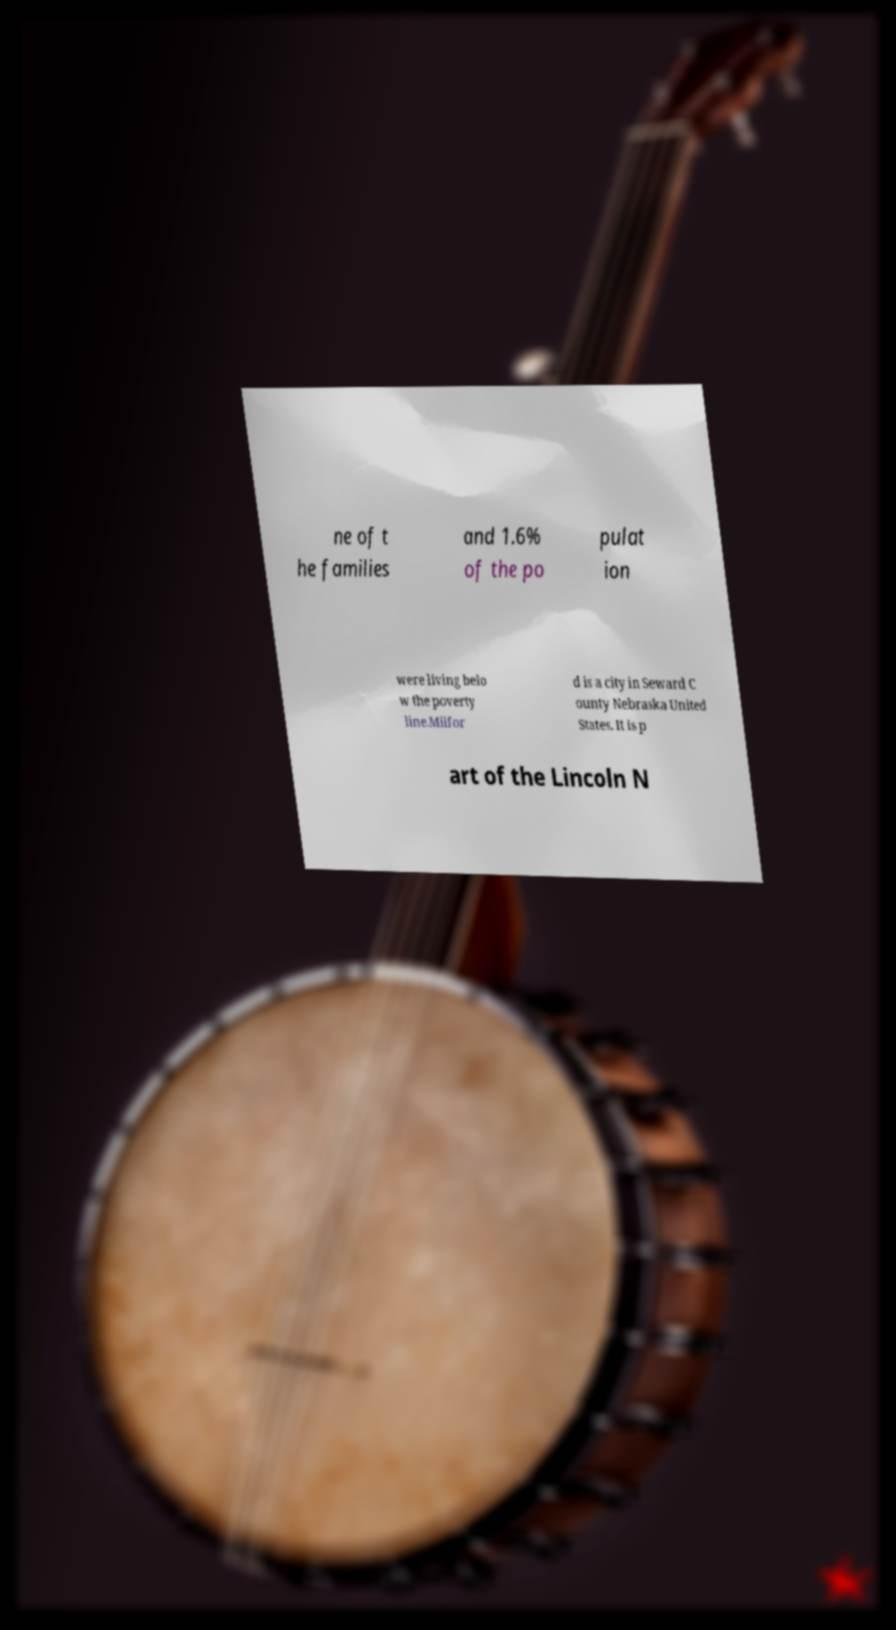What messages or text are displayed in this image? I need them in a readable, typed format. ne of t he families and 1.6% of the po pulat ion were living belo w the poverty line.Milfor d is a city in Seward C ounty Nebraska United States. It is p art of the Lincoln N 